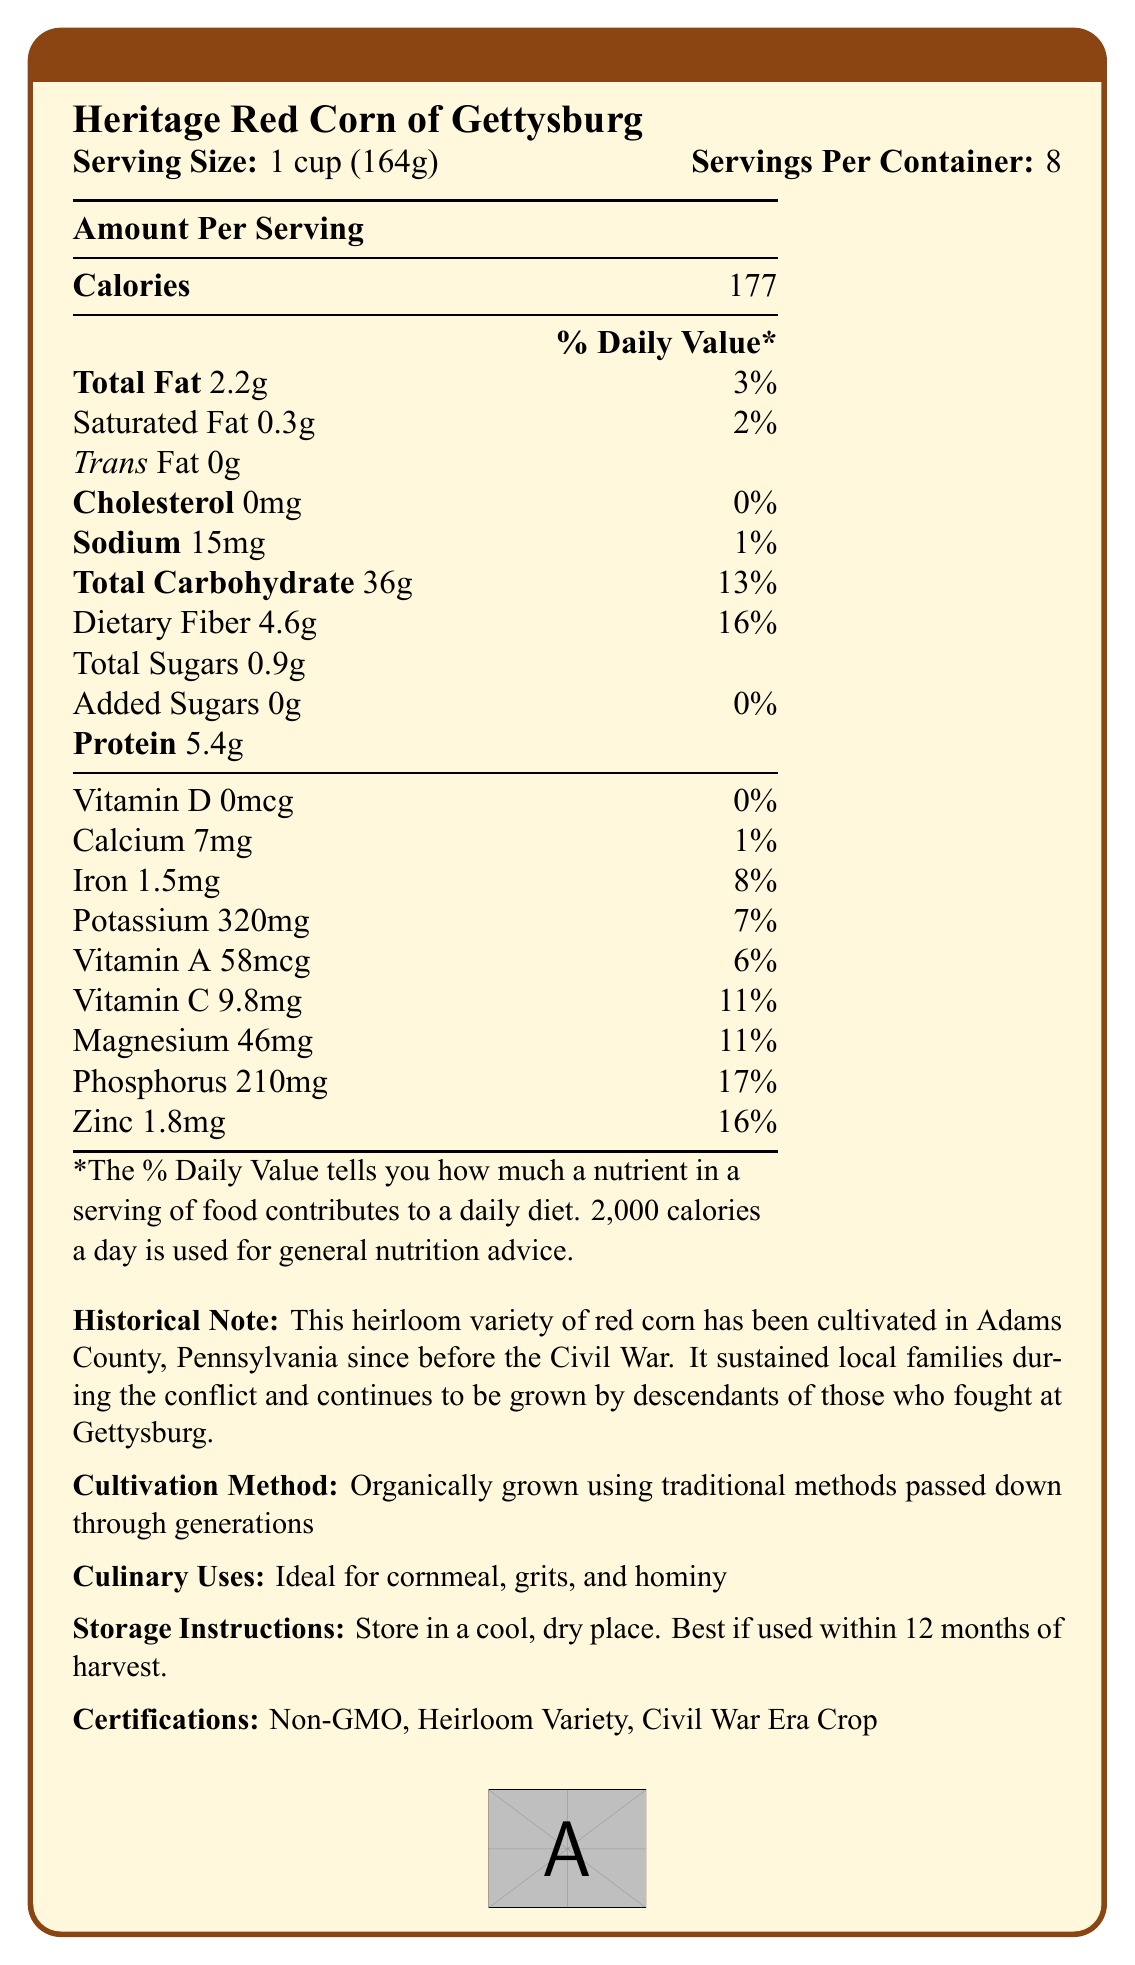what is the serving size of Heritage Red Corn of Gettysburg? The serving size is directly mentioned as "1 cup (164g)".
Answer: 1 cup (164g) how many calories are in a single serving of this product? The calories per serving are directly listed as 177.
Answer: 177 what is the amount of dietary fiber in one serving? The dietary fiber content per serving is specified as 4.6g.
Answer: 4.6g what is the percent daily value of phosphorus? The percent daily value of phosphorus is displayed as 17%.
Answer: 17% what certifications does the Heritage Red Corn of Gettysburg have? The certifications are listed at the end of the document.
Answer: Non-GMO, Heirloom Variety, Civil War Era Crop how much protein does one serving contain? A. 2g B. 3g C. 5.4g D. 8g The protein content per serving is noted as 5.4g.
Answer: C what is the main vitamin content noticeable in this product? A. Vitamin D B. Vitamin A C. Vitamin B12 D. Vitamin E Among the listed vitamins, Vitamin A (58mcg) is prominently mentioned, while Vitamins D, B12, and E are not listed.
Answer: B does this product contain any trans fat? The document mentions that the product contains 0g of trans fat.
Answer: No how should this product be stored? The storage instructions specify storing in a cool, dry place and using within 12 months of harvest.
Answer: Store in a cool, dry place. Best if used within 12 months of harvest. summarize the main nutritional benefits and historical importance of Heritage Red Corn of Gettysburg. The summary covers the nutritional value, such as carbohydrates, fiber, protein, and essential minerals. It also touches on the historical note given in the document about its cultivation and importance during the Civil War.
Answer: The Heritage Red Corn of Gettysburg is a nutritionally rich heirloom variety with a balanced amount of carbohydrates, fiber, protein, and essential minerals such as magnesium, phosphorus, and zinc. It holds historical significance as it has been cultivated since before the Civil War and sustained local families during the conflict. what year was the Heritage Red Corn of Gettysburg first cultivated? The document does not provide the specific year of first cultivation.
Answer: Not enough information how much sodium is in one serving? The sodium content per serving is listed as 15mg.
Answer: 15mg what traditional uses are mentioned for this corn? The culinary uses specify that the corn is ideal for cornmeal, grits, and hominy.
Answer: Ideal for cornmeal, grits, and hominy what is the percent daily value of calcium in this product? The percent daily value of calcium is listed as 1%.
Answer: 1% what historical conflict is associated with the cultivation of this corn variety? The historical note mentions that this corn has been cultivated since before the Civil War and sustained local families during the conflict.
Answer: The Civil War 